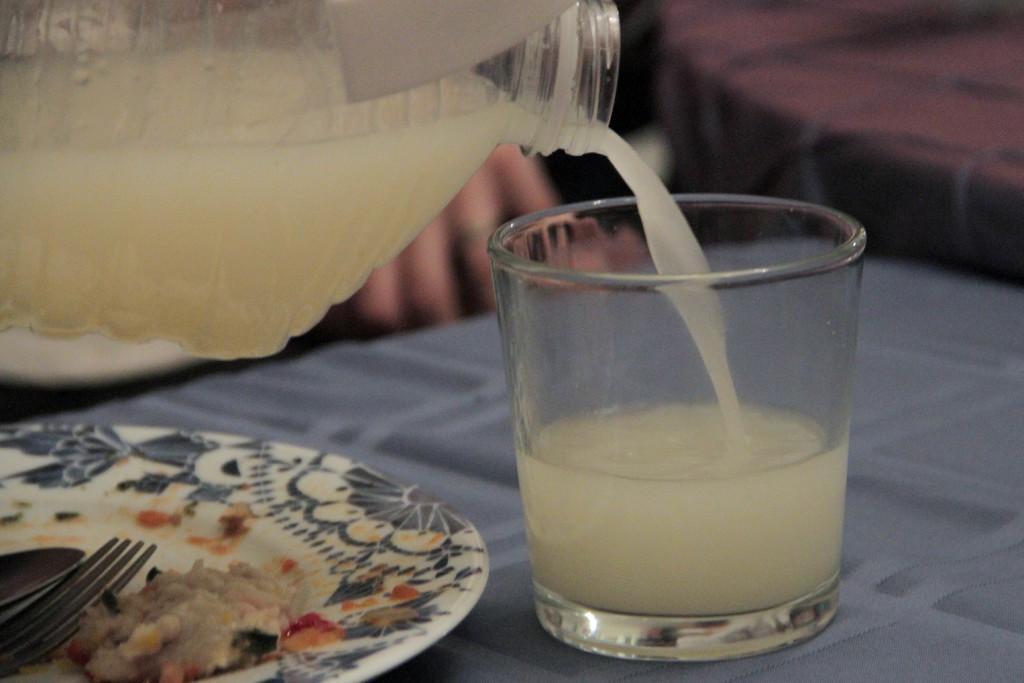What objects are in the foreground of the picture? There is a glass, a bottle, a drink, a plate, and wood in the foreground of the picture. What type of surface is the glass and bottle placed on? The glass and bottle are placed on a table in the foreground of the picture. What material is the table made of? The table is made of wood, as mentioned in the facts. How is the background of the image depicted? The background of the image is blurred. Can you see any celery on the plate in the image? There is no celery present on the plate in the image. What type of bone is visible in the image? There is no bone visible in the image. 